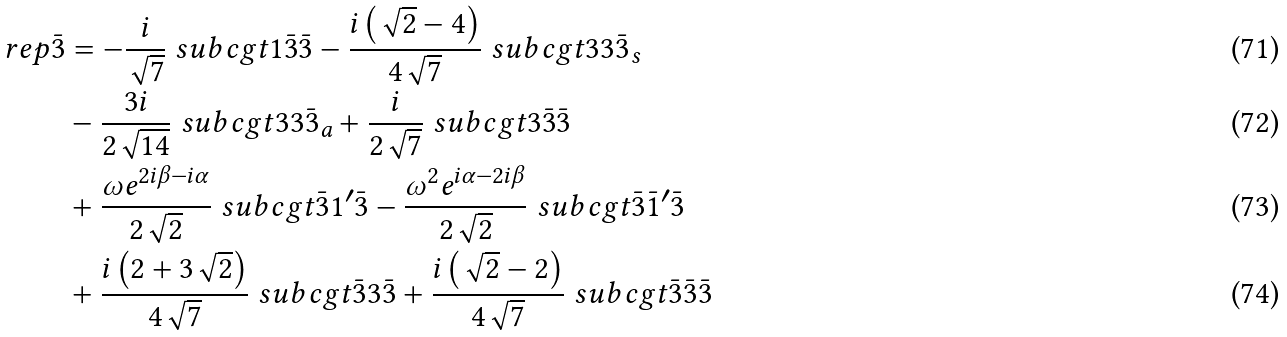<formula> <loc_0><loc_0><loc_500><loc_500>\ r e p { \bar { 3 } } & = - \frac { i } { \sqrt { 7 } } \ s u b c g t { 1 } { \bar { 3 } } { \bar { 3 } } - \frac { i \left ( \sqrt { 2 } - 4 \right ) } { 4 \sqrt { 7 } } \ s u b c g t { 3 } { 3 } { \bar { 3 } _ { s } } \\ & - \frac { 3 i } { 2 \sqrt { 1 4 } } \ s u b c g t { 3 } { 3 } { \bar { 3 } _ { a } } + \frac { i } { 2 \sqrt { 7 } } \ s u b c g t { 3 } { \bar { 3 } } { \bar { 3 } } \\ & + \frac { \omega e ^ { 2 i \beta - i \alpha } } { 2 \sqrt { 2 } } \ s u b c g t { \bar { 3 } } { 1 ^ { \prime } } { \bar { 3 } } - \frac { \omega ^ { 2 } e ^ { i \alpha - 2 i \beta } } { 2 \sqrt { 2 } } \ s u b c g t { \bar { 3 } } { \bar { 1 } ^ { \prime } } { \bar { 3 } } \\ & + \frac { i \left ( 2 + 3 \sqrt { 2 } \right ) } { 4 \sqrt { 7 } } \ s u b c g t { \bar { 3 } } { 3 } { \bar { 3 } } + \frac { i \left ( \sqrt { 2 } - 2 \right ) } { 4 \sqrt { 7 } } \ s u b c g t { \bar { 3 } } { \bar { 3 } } { \bar { 3 } }</formula> 